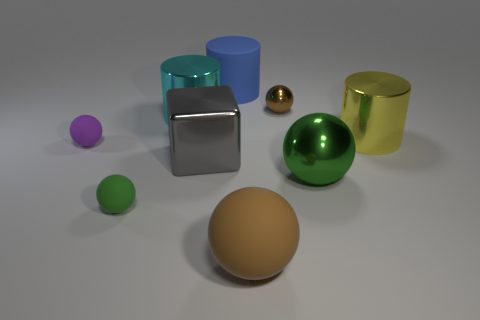Are there an equal number of brown spheres left of the cyan cylinder and tiny cyan rubber things?
Offer a very short reply. Yes. How many objects are small things to the right of the large gray block or large gray cylinders?
Offer a very short reply. 1. There is a big object that is both left of the big green sphere and in front of the large block; what shape is it?
Give a very brief answer. Sphere. What number of things are purple balls left of the big yellow cylinder or green spheres on the right side of the large blue thing?
Ensure brevity in your answer.  2. How many other objects are the same size as the cube?
Provide a short and direct response. 5. There is a small matte object in front of the big green object; is its color the same as the big block?
Your response must be concise. No. What size is the cylinder that is both to the right of the big cyan object and left of the yellow cylinder?
Your answer should be very brief. Large. How many big objects are purple rubber things or spheres?
Provide a succinct answer. 2. What is the shape of the green object that is to the left of the rubber cylinder?
Keep it short and to the point. Sphere. What number of large metallic things are there?
Give a very brief answer. 4. 